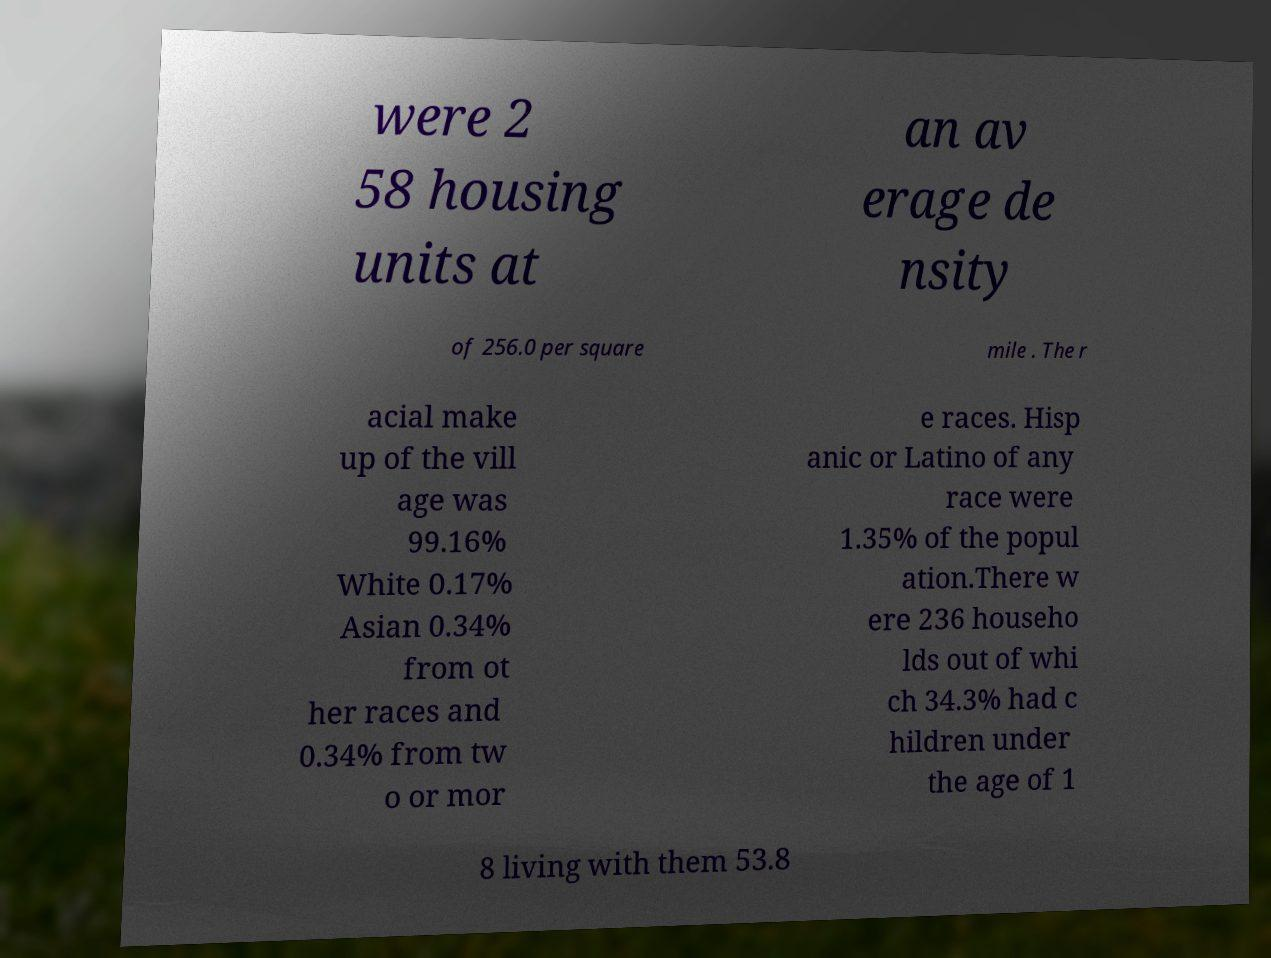Can you accurately transcribe the text from the provided image for me? were 2 58 housing units at an av erage de nsity of 256.0 per square mile . The r acial make up of the vill age was 99.16% White 0.17% Asian 0.34% from ot her races and 0.34% from tw o or mor e races. Hisp anic or Latino of any race were 1.35% of the popul ation.There w ere 236 househo lds out of whi ch 34.3% had c hildren under the age of 1 8 living with them 53.8 